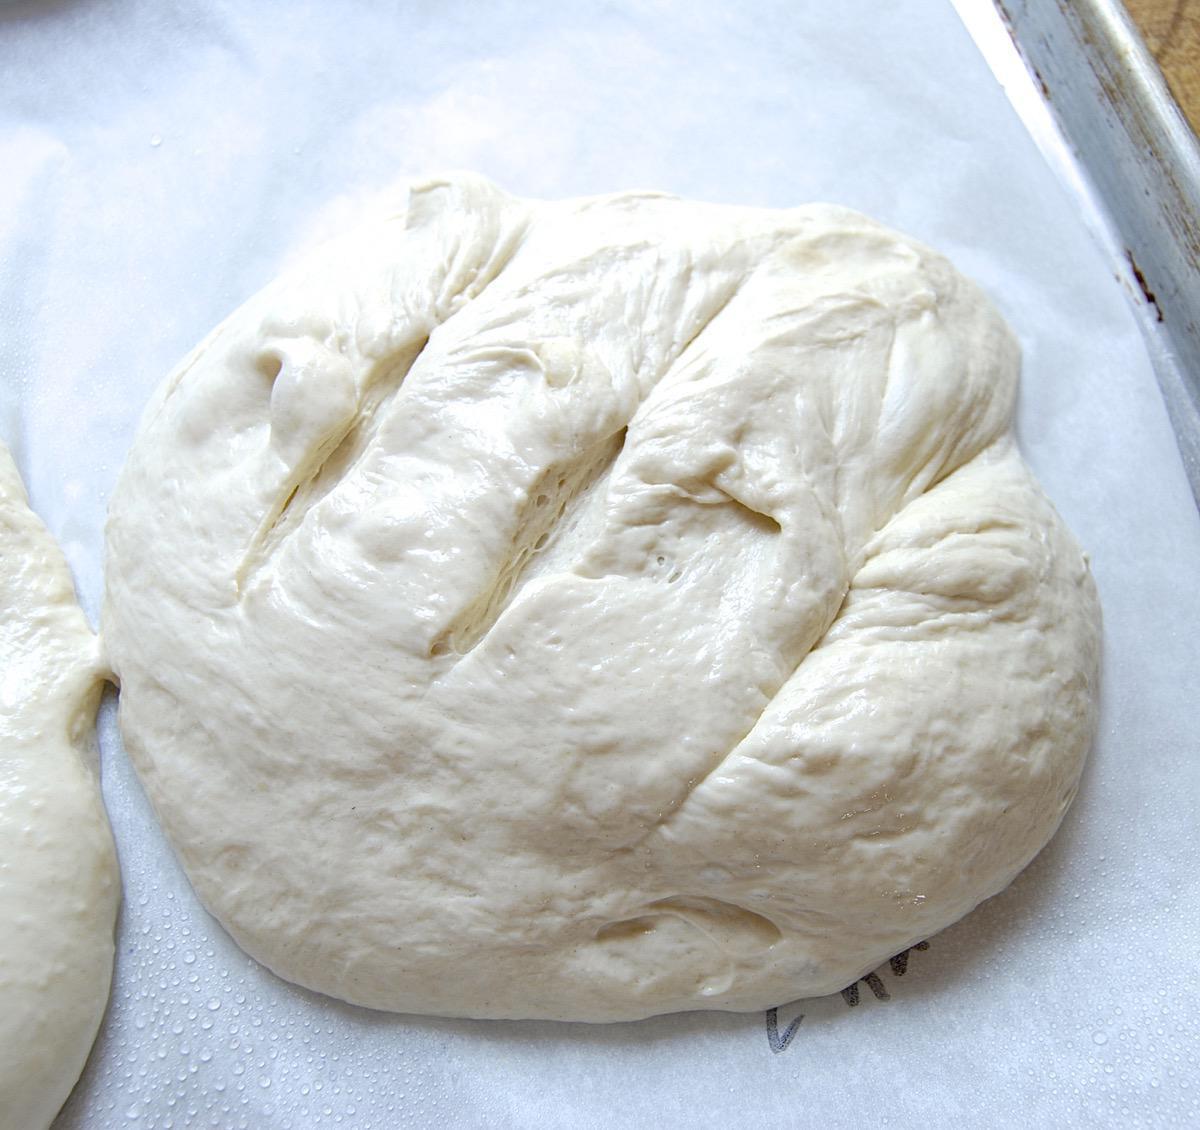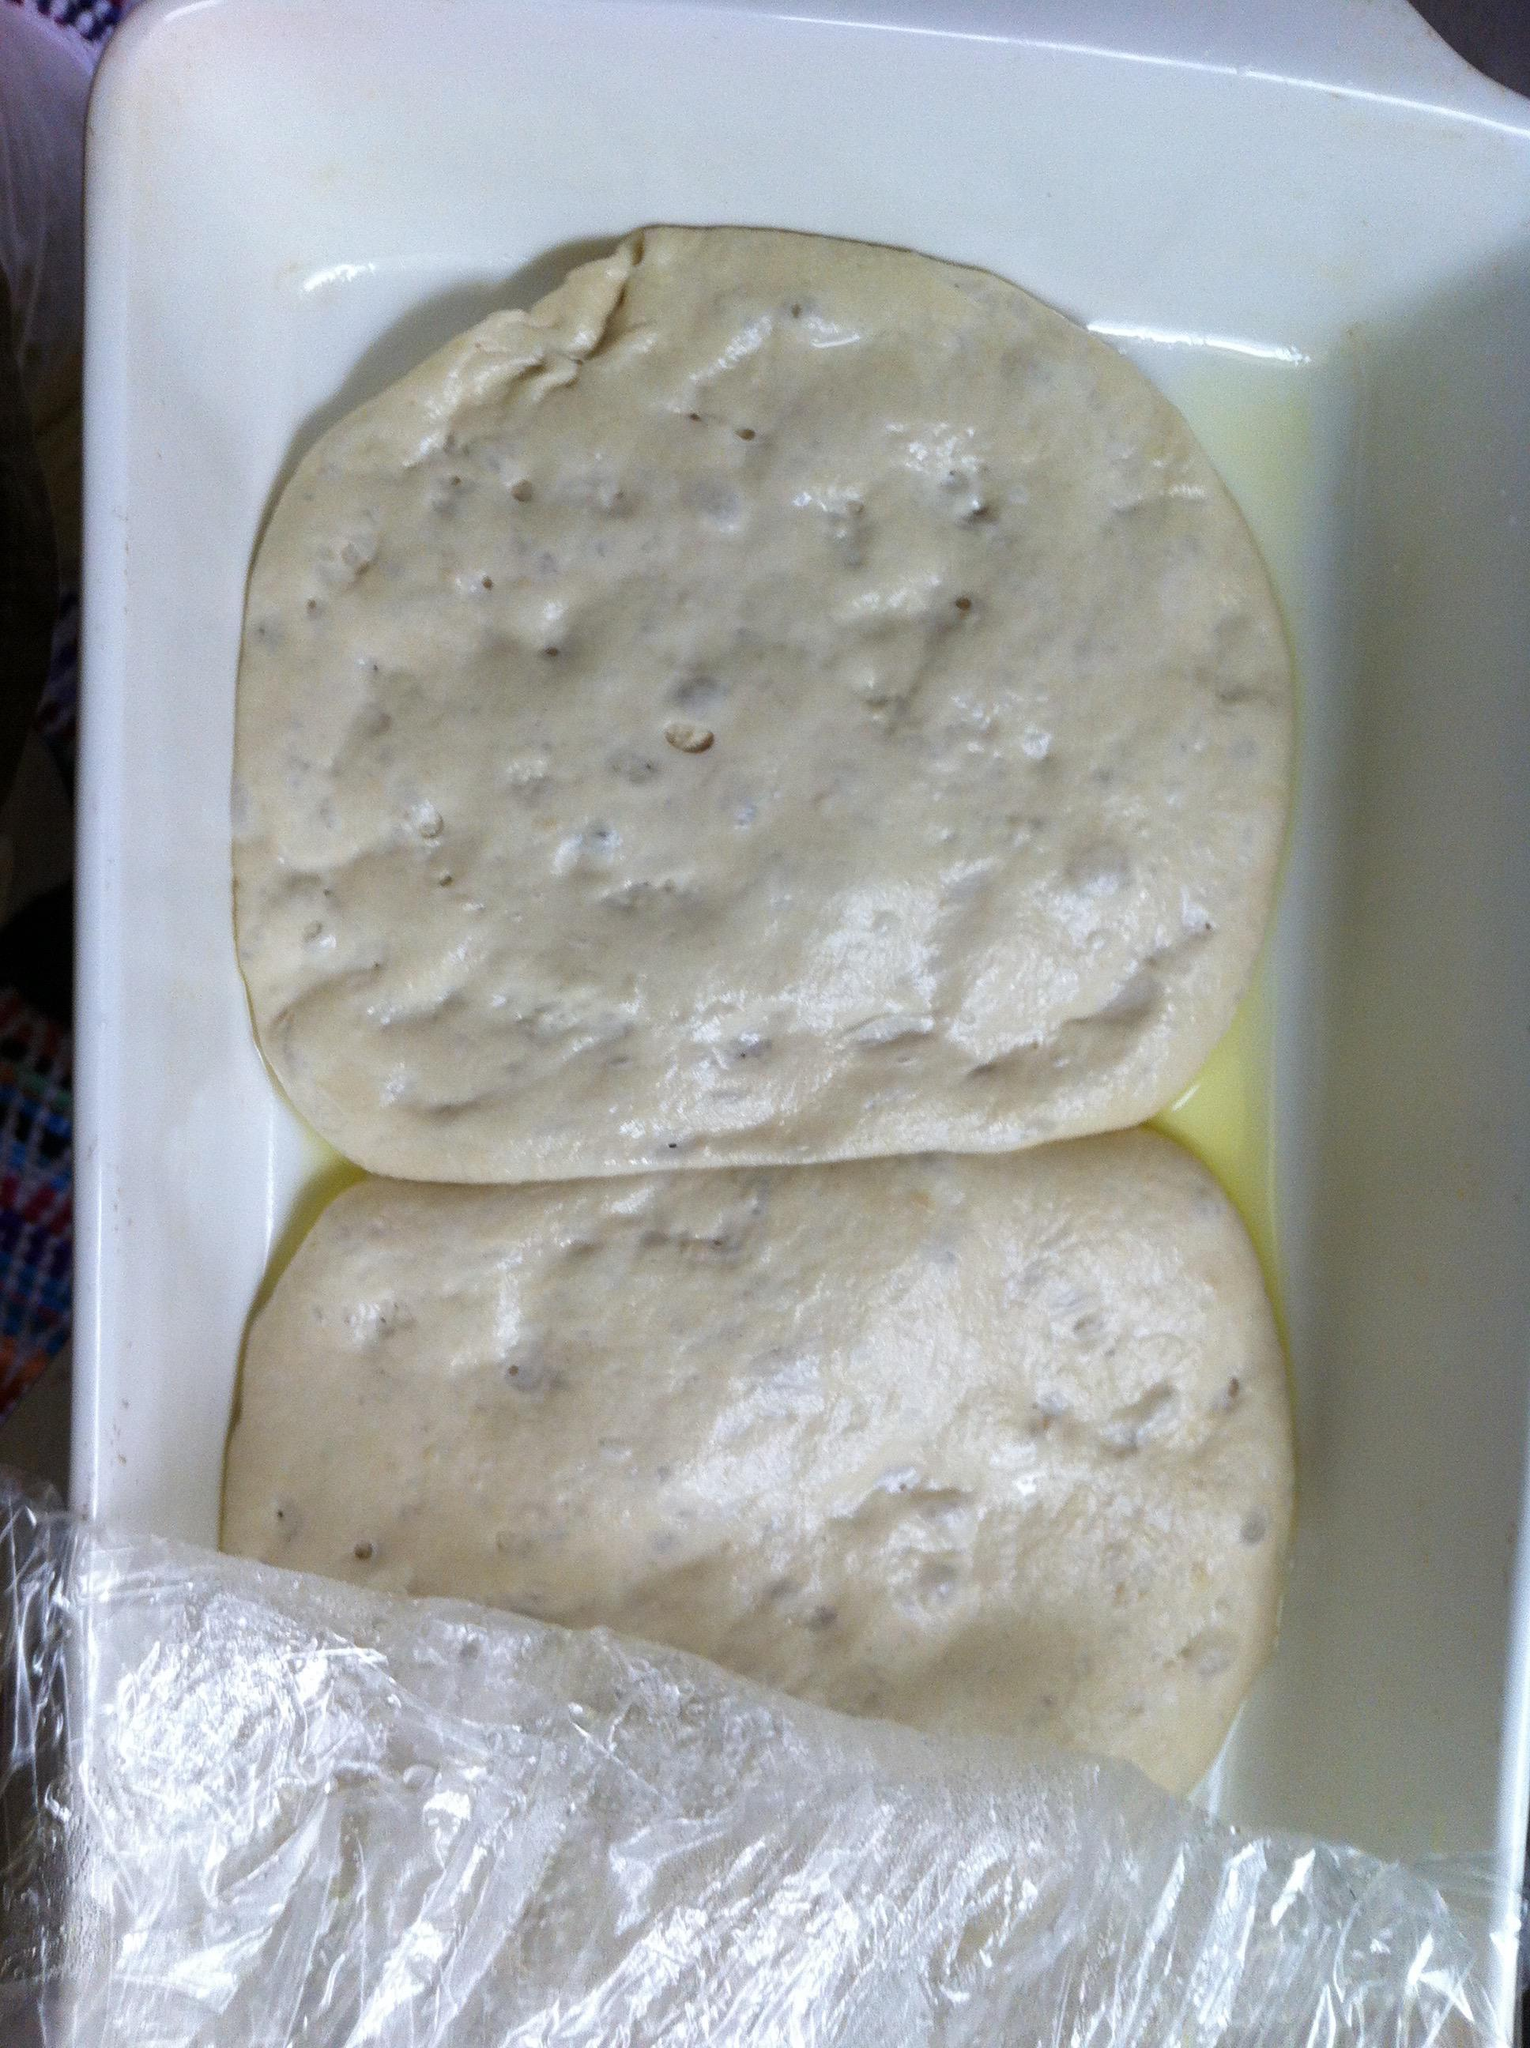The first image is the image on the left, the second image is the image on the right. Given the left and right images, does the statement "IN at least one image there is kneaded bread next to a single bowl of flower." hold true? Answer yes or no. No. 